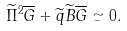Convert formula to latex. <formula><loc_0><loc_0><loc_500><loc_500>\widetilde { \Pi } ^ { 2 } \overline { G } + \widetilde { q } \widetilde { B } \overline { G } \simeq 0 .</formula> 